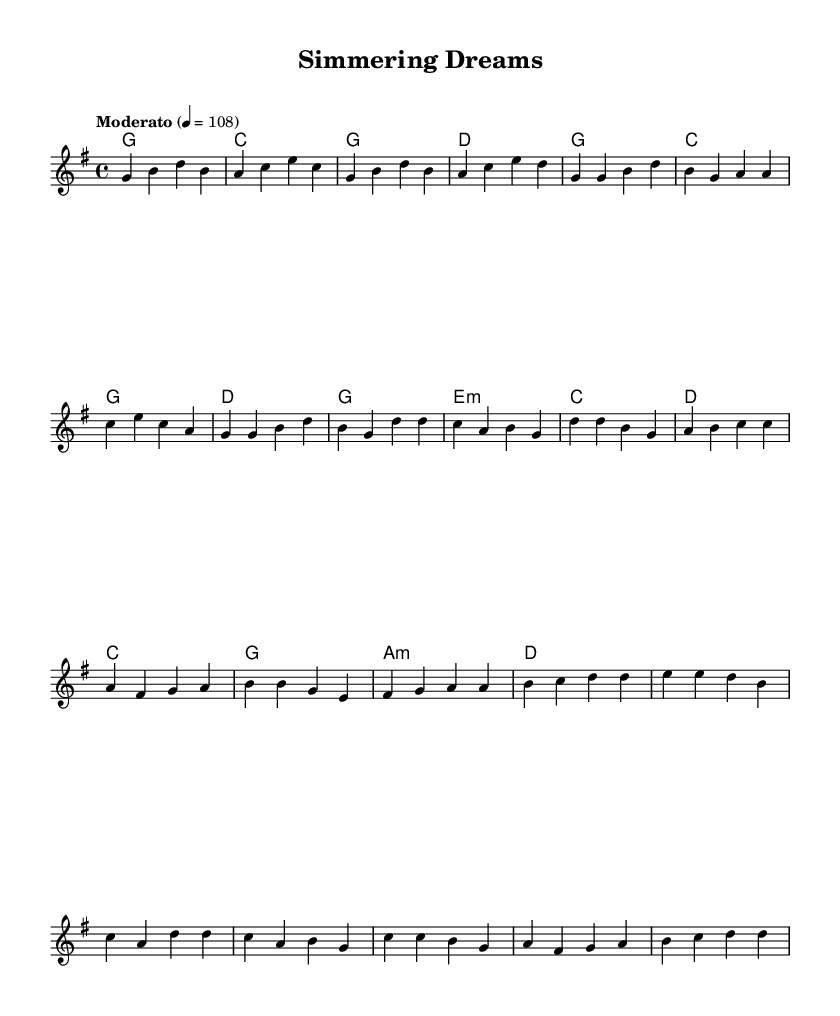What is the key signature of this music? The key signature is indicated by the absence of sharps or flats in the score. The note that is commonly referred to as 'G' contains one sharp, which implies that it is in G major.
Answer: G major What is the time signature of this music? The time signature is located at the beginning of the score. It is written as "4/4," which indicates that there are four beats in each measure and a quarter note receives one beat.
Answer: 4/4 What is the tempo marking of this music? The tempo marking is found in the score, specified as "Moderato" with a metronome marking of 108. This means the piece should be played at a moderate pace.
Answer: Moderato How many measures are there in the chorus? By counting the sets of four beats indicated in the score, we determine how many measure groups are present in the chorus section. There are four measures in the chorus.
Answer: Four What is the predominant mood conveyed in the music? The mood can be inferred from the combination of major keys, moderate tempo, and the nature of the melody and harmony, which tends to evoke a sense of warmth and optimism typical of indie folk tunes that convey passion.
Answer: Optimistic What is the relationship between the verse and chorus in this music? The relationship can be analyzed through both melody and harmony; the verses and the choruses are structurally distinct but share similar chord progressions, which gives a unified feel to the song. The verse ends with a strong resolution to the chorus.
Answer: Unified feel What narrative does the music theme convey related to culinary arts? Analyzing the song's title and its uplifting nature suggests a focus on realizing one's dreams and passions, likely relating to the journey involved in pursuing a career in culinary arts, highlighting perseverance and joy.
Answer: Pursuing passion 